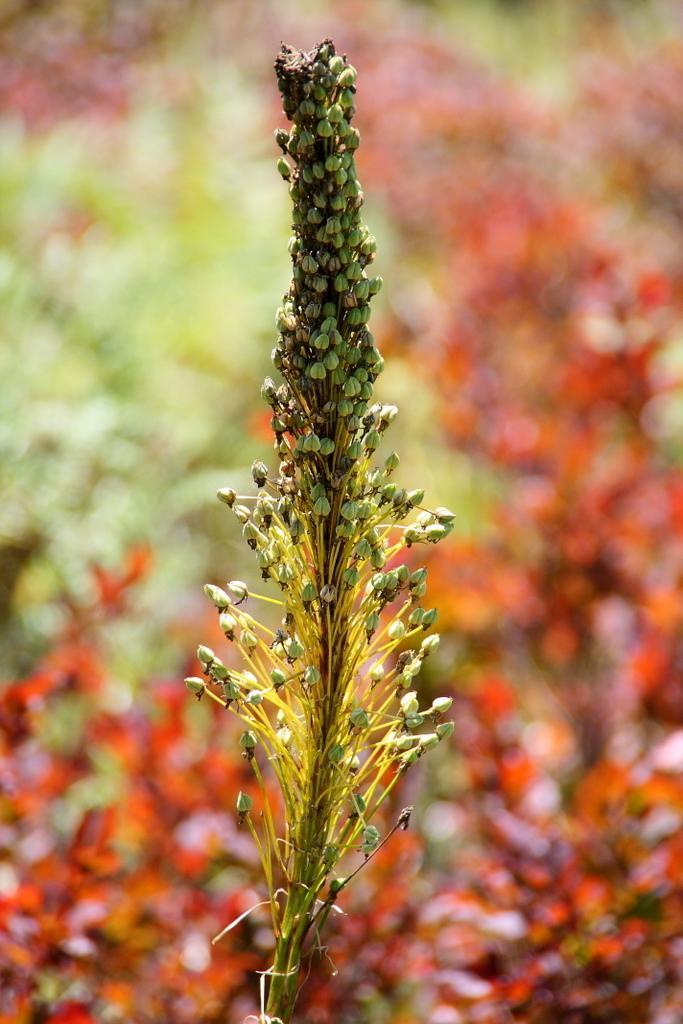Please provide a concise description of this image. In this picture, we see a plant which has flowers or buds. These flowers are in green color. In the background, it is in green and red color. It is blurred in the background. 